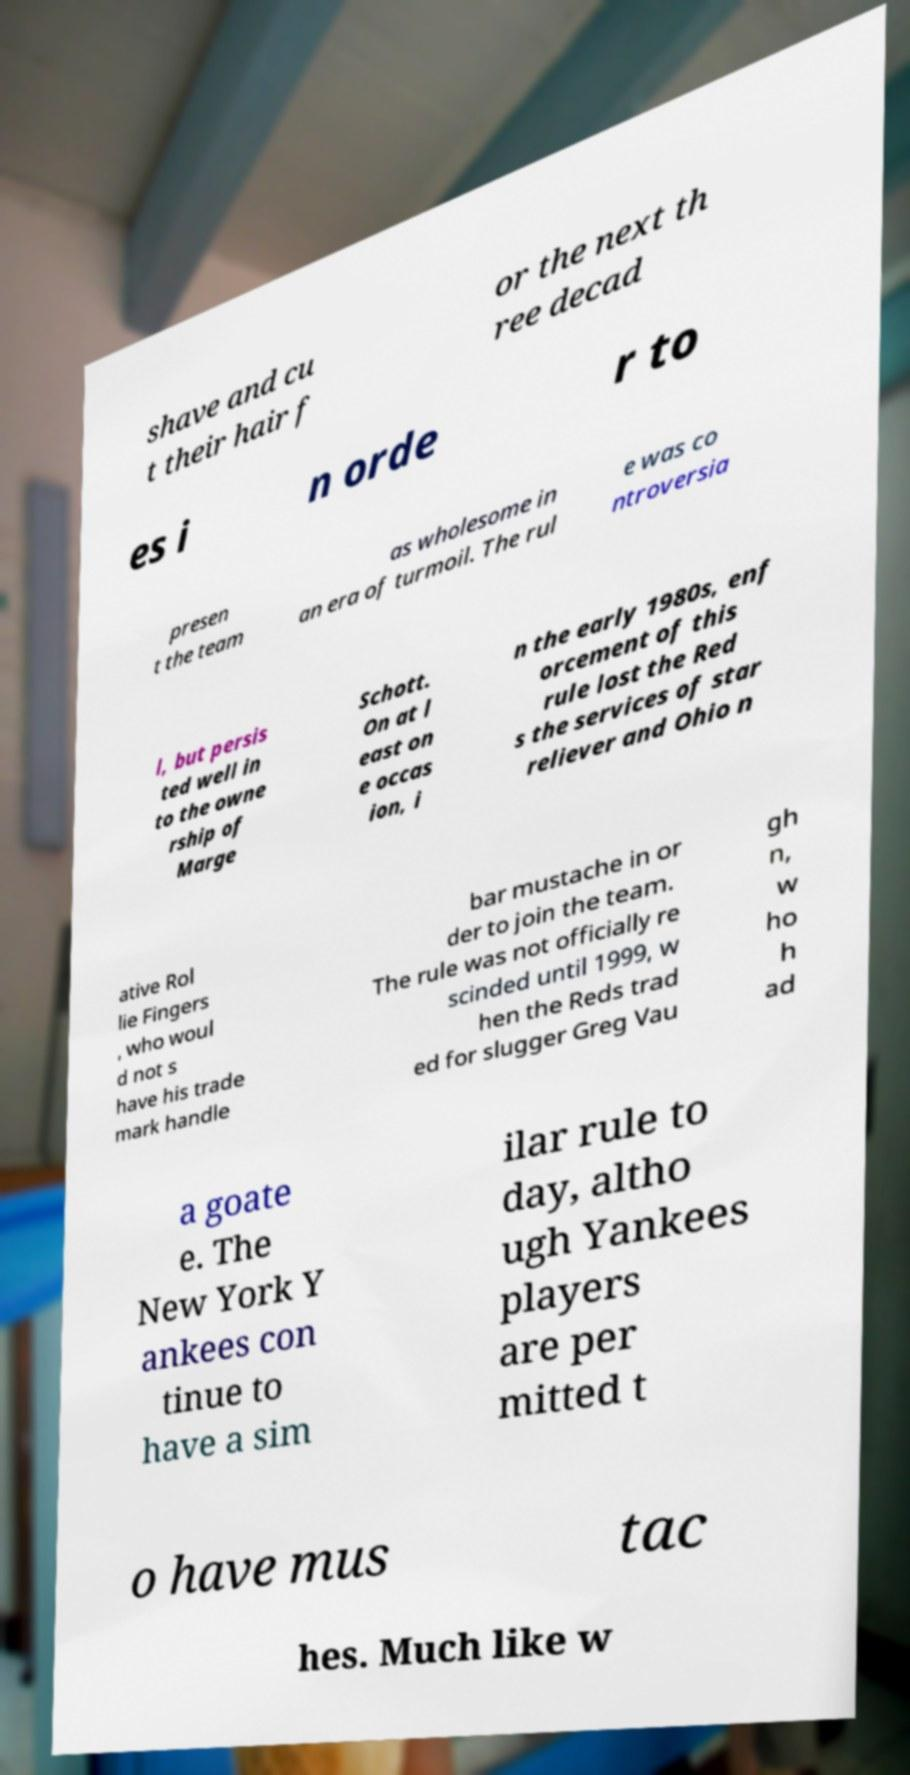Can you accurately transcribe the text from the provided image for me? shave and cu t their hair f or the next th ree decad es i n orde r to presen t the team as wholesome in an era of turmoil. The rul e was co ntroversia l, but persis ted well in to the owne rship of Marge Schott. On at l east on e occas ion, i n the early 1980s, enf orcement of this rule lost the Red s the services of star reliever and Ohio n ative Rol lie Fingers , who woul d not s have his trade mark handle bar mustache in or der to join the team. The rule was not officially re scinded until 1999, w hen the Reds trad ed for slugger Greg Vau gh n, w ho h ad a goate e. The New York Y ankees con tinue to have a sim ilar rule to day, altho ugh Yankees players are per mitted t o have mus tac hes. Much like w 